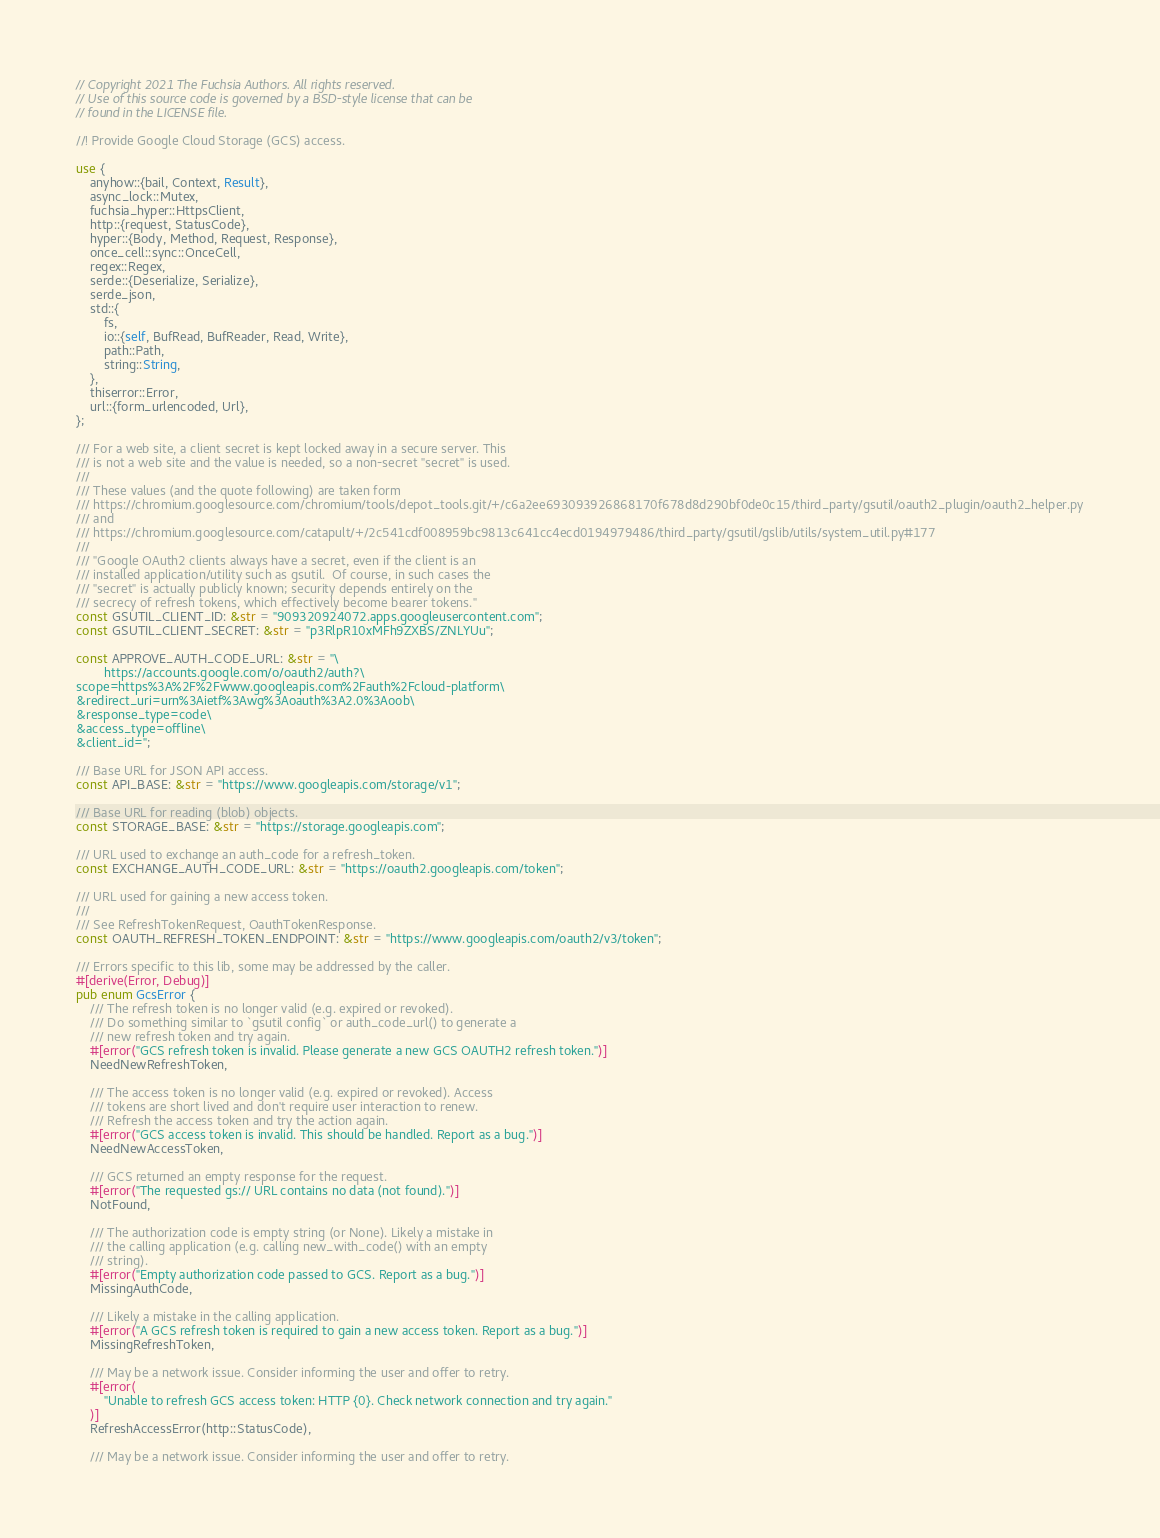<code> <loc_0><loc_0><loc_500><loc_500><_Rust_>// Copyright 2021 The Fuchsia Authors. All rights reserved.
// Use of this source code is governed by a BSD-style license that can be
// found in the LICENSE file.

//! Provide Google Cloud Storage (GCS) access.

use {
    anyhow::{bail, Context, Result},
    async_lock::Mutex,
    fuchsia_hyper::HttpsClient,
    http::{request, StatusCode},
    hyper::{Body, Method, Request, Response},
    once_cell::sync::OnceCell,
    regex::Regex,
    serde::{Deserialize, Serialize},
    serde_json,
    std::{
        fs,
        io::{self, BufRead, BufReader, Read, Write},
        path::Path,
        string::String,
    },
    thiserror::Error,
    url::{form_urlencoded, Url},
};

/// For a web site, a client secret is kept locked away in a secure server. This
/// is not a web site and the value is needed, so a non-secret "secret" is used.
///
/// These values (and the quote following) are taken form
/// https://chromium.googlesource.com/chromium/tools/depot_tools.git/+/c6a2ee693093926868170f678d8d290bf0de0c15/third_party/gsutil/oauth2_plugin/oauth2_helper.py
/// and
/// https://chromium.googlesource.com/catapult/+/2c541cdf008959bc9813c641cc4ecd0194979486/third_party/gsutil/gslib/utils/system_util.py#177
///
/// "Google OAuth2 clients always have a secret, even if the client is an
/// installed application/utility such as gsutil.  Of course, in such cases the
/// "secret" is actually publicly known; security depends entirely on the
/// secrecy of refresh tokens, which effectively become bearer tokens."
const GSUTIL_CLIENT_ID: &str = "909320924072.apps.googleusercontent.com";
const GSUTIL_CLIENT_SECRET: &str = "p3RlpR10xMFh9ZXBS/ZNLYUu";

const APPROVE_AUTH_CODE_URL: &str = "\
        https://accounts.google.com/o/oauth2/auth?\
scope=https%3A%2F%2Fwww.googleapis.com%2Fauth%2Fcloud-platform\
&redirect_uri=urn%3Aietf%3Awg%3Aoauth%3A2.0%3Aoob\
&response_type=code\
&access_type=offline\
&client_id=";

/// Base URL for JSON API access.
const API_BASE: &str = "https://www.googleapis.com/storage/v1";

/// Base URL for reading (blob) objects.
const STORAGE_BASE: &str = "https://storage.googleapis.com";

/// URL used to exchange an auth_code for a refresh_token.
const EXCHANGE_AUTH_CODE_URL: &str = "https://oauth2.googleapis.com/token";

/// URL used for gaining a new access token.
///
/// See RefreshTokenRequest, OauthTokenResponse.
const OAUTH_REFRESH_TOKEN_ENDPOINT: &str = "https://www.googleapis.com/oauth2/v3/token";

/// Errors specific to this lib, some may be addressed by the caller.
#[derive(Error, Debug)]
pub enum GcsError {
    /// The refresh token is no longer valid (e.g. expired or revoked).
    /// Do something similar to `gsutil config` or auth_code_url() to generate a
    /// new refresh token and try again.
    #[error("GCS refresh token is invalid. Please generate a new GCS OAUTH2 refresh token.")]
    NeedNewRefreshToken,

    /// The access token is no longer valid (e.g. expired or revoked). Access
    /// tokens are short lived and don't require user interaction to renew.
    /// Refresh the access token and try the action again.
    #[error("GCS access token is invalid. This should be handled. Report as a bug.")]
    NeedNewAccessToken,

    /// GCS returned an empty response for the request.
    #[error("The requested gs:// URL contains no data (not found).")]
    NotFound,

    /// The authorization code is empty string (or None). Likely a mistake in
    /// the calling application (e.g. calling new_with_code() with an empty
    /// string).
    #[error("Empty authorization code passed to GCS. Report as a bug.")]
    MissingAuthCode,

    /// Likely a mistake in the calling application.
    #[error("A GCS refresh token is required to gain a new access token. Report as a bug.")]
    MissingRefreshToken,

    /// May be a network issue. Consider informing the user and offer to retry.
    #[error(
        "Unable to refresh GCS access token: HTTP {0}. Check network connection and try again."
    )]
    RefreshAccessError(http::StatusCode),

    /// May be a network issue. Consider informing the user and offer to retry.</code> 